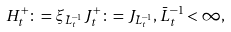Convert formula to latex. <formula><loc_0><loc_0><loc_500><loc_500>H ^ { + } _ { t } \colon = \xi _ { \bar { L } ^ { - 1 } _ { t } } J ^ { + } _ { t } \colon = J _ { \bar { L } ^ { - 1 } _ { t } } , \bar { L } ^ { - 1 } _ { t } < \infty ,</formula> 